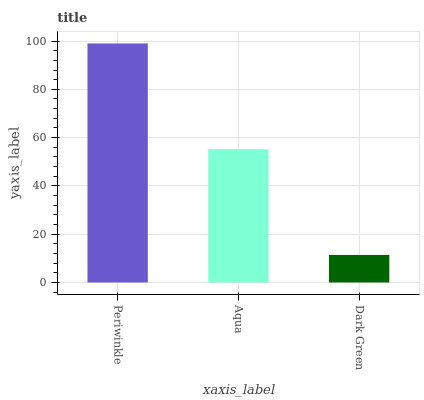Is Dark Green the minimum?
Answer yes or no. Yes. Is Periwinkle the maximum?
Answer yes or no. Yes. Is Aqua the minimum?
Answer yes or no. No. Is Aqua the maximum?
Answer yes or no. No. Is Periwinkle greater than Aqua?
Answer yes or no. Yes. Is Aqua less than Periwinkle?
Answer yes or no. Yes. Is Aqua greater than Periwinkle?
Answer yes or no. No. Is Periwinkle less than Aqua?
Answer yes or no. No. Is Aqua the high median?
Answer yes or no. Yes. Is Aqua the low median?
Answer yes or no. Yes. Is Periwinkle the high median?
Answer yes or no. No. Is Periwinkle the low median?
Answer yes or no. No. 